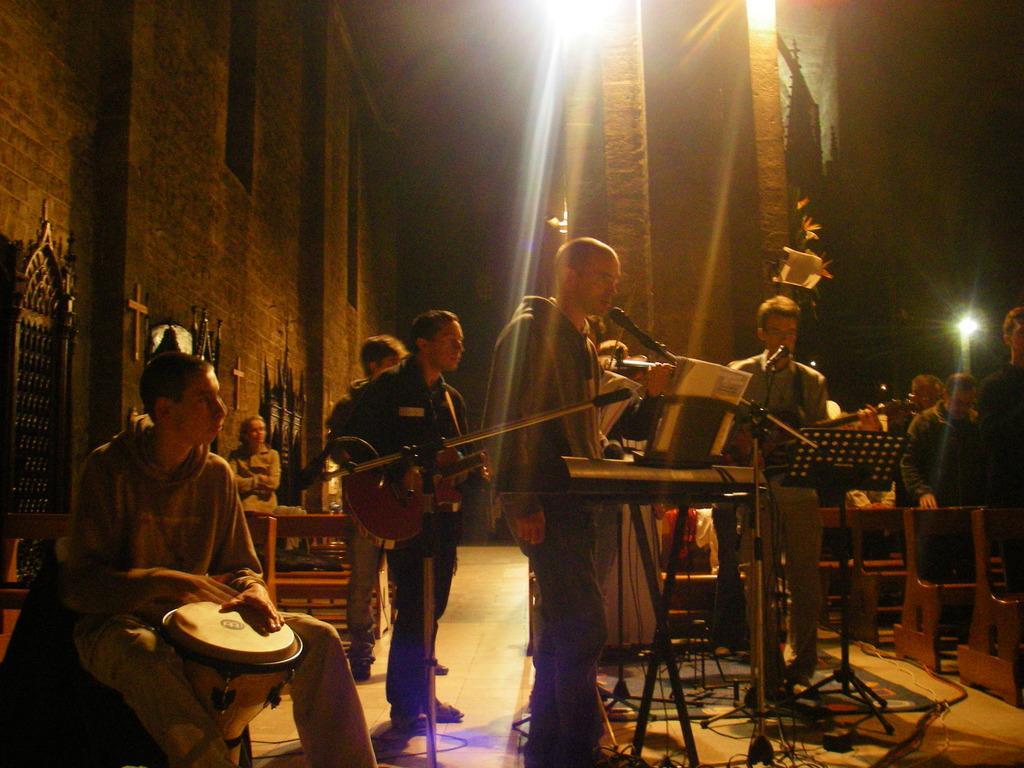How would you summarize this image in a sentence or two? A band of musicians are playing music in a concert. 